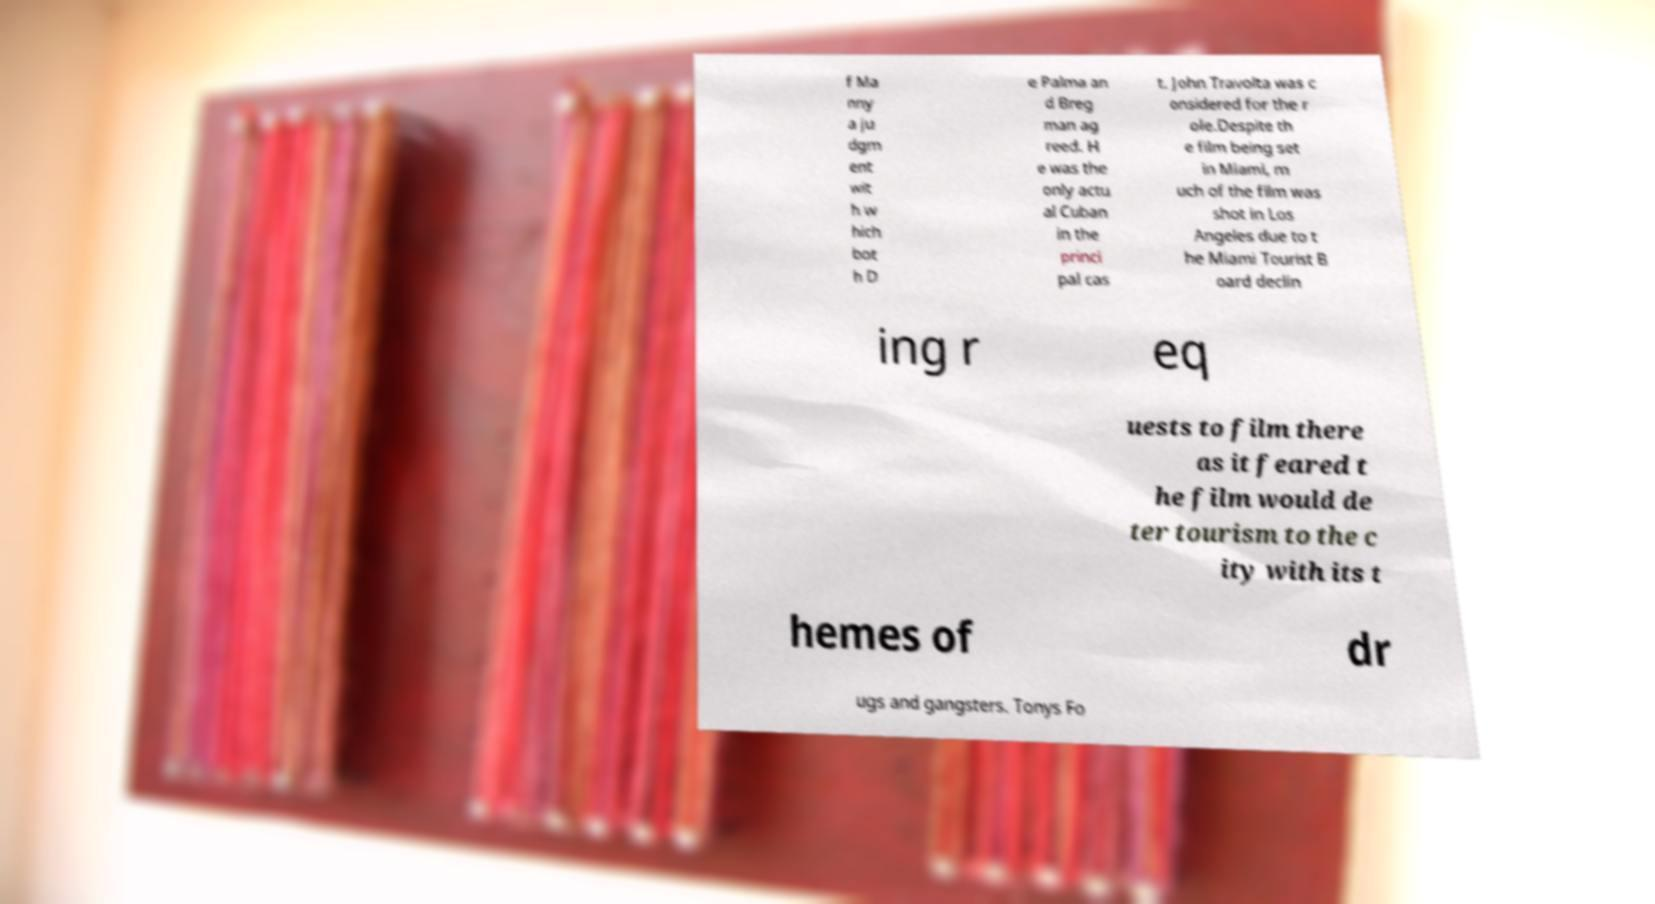There's text embedded in this image that I need extracted. Can you transcribe it verbatim? f Ma nny a ju dgm ent wit h w hich bot h D e Palma an d Breg man ag reed. H e was the only actu al Cuban in the princi pal cas t. John Travolta was c onsidered for the r ole.Despite th e film being set in Miami, m uch of the film was shot in Los Angeles due to t he Miami Tourist B oard declin ing r eq uests to film there as it feared t he film would de ter tourism to the c ity with its t hemes of dr ugs and gangsters. Tonys Fo 